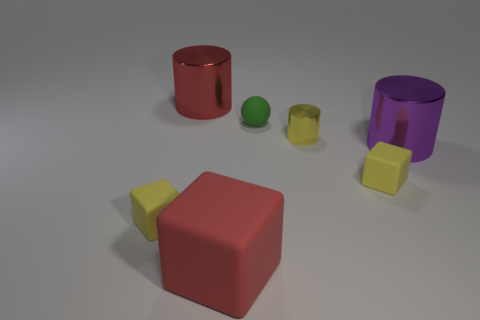Is the number of large red cylinders that are in front of the big purple cylinder less than the number of big purple objects?
Offer a very short reply. Yes. There is a large red object that is on the left side of the red object that is in front of the red metallic cylinder; what is it made of?
Offer a very short reply. Metal. There is a big thing that is left of the small green thing and in front of the small green ball; what shape is it?
Your response must be concise. Cube. How many other things are there of the same color as the tiny ball?
Provide a short and direct response. 0. How many things are either matte things that are left of the large red rubber block or rubber things?
Provide a short and direct response. 4. Does the large block have the same color as the big cylinder left of the big purple cylinder?
Keep it short and to the point. Yes. Is there anything else that has the same size as the green thing?
Your answer should be very brief. Yes. There is a yellow block that is behind the rubber block that is left of the big red metallic object; what is its size?
Offer a terse response. Small. What number of things are large rubber cubes or tiny rubber things that are in front of the green ball?
Your answer should be very brief. 3. Do the big shiny object on the left side of the purple cylinder and the green rubber thing have the same shape?
Give a very brief answer. No. 